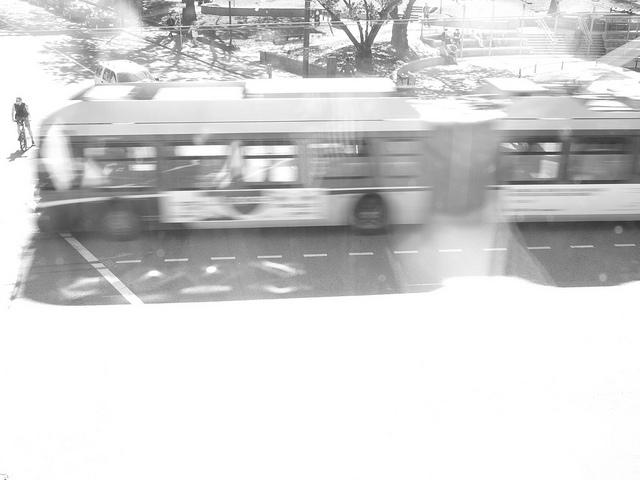Is this photo in black and white or color?
Write a very short answer. Black and white. How many people are seen?
Short answer required. 1. Is the bus in motion?
Write a very short answer. Yes. 